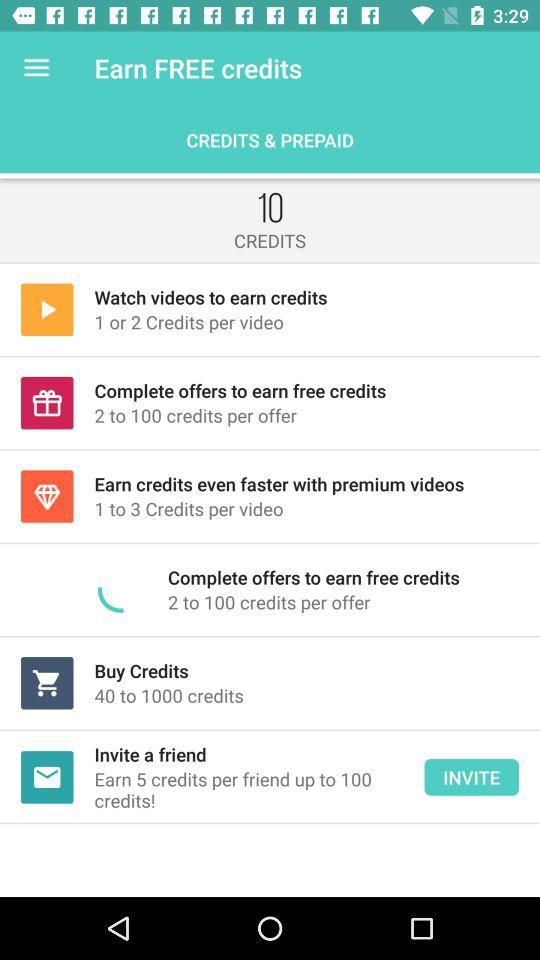How many credits can I earn per offer?
Answer the question using a single word or phrase. 2 to 100 